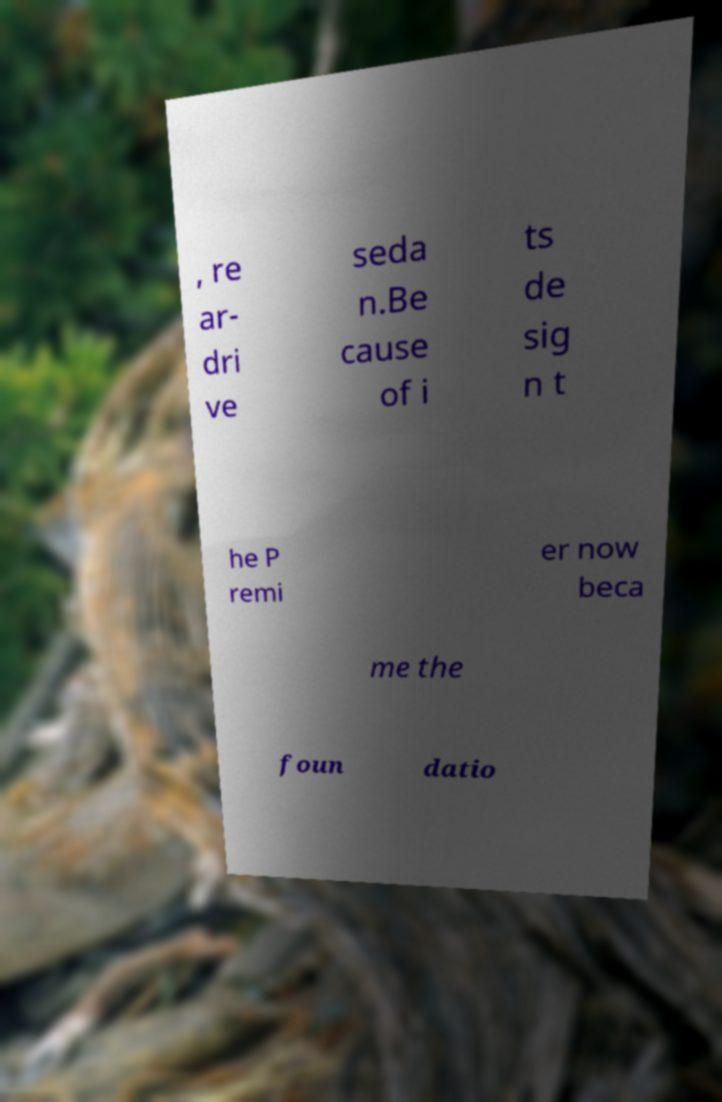Please read and relay the text visible in this image. What does it say? , re ar- dri ve seda n.Be cause of i ts de sig n t he P remi er now beca me the foun datio 